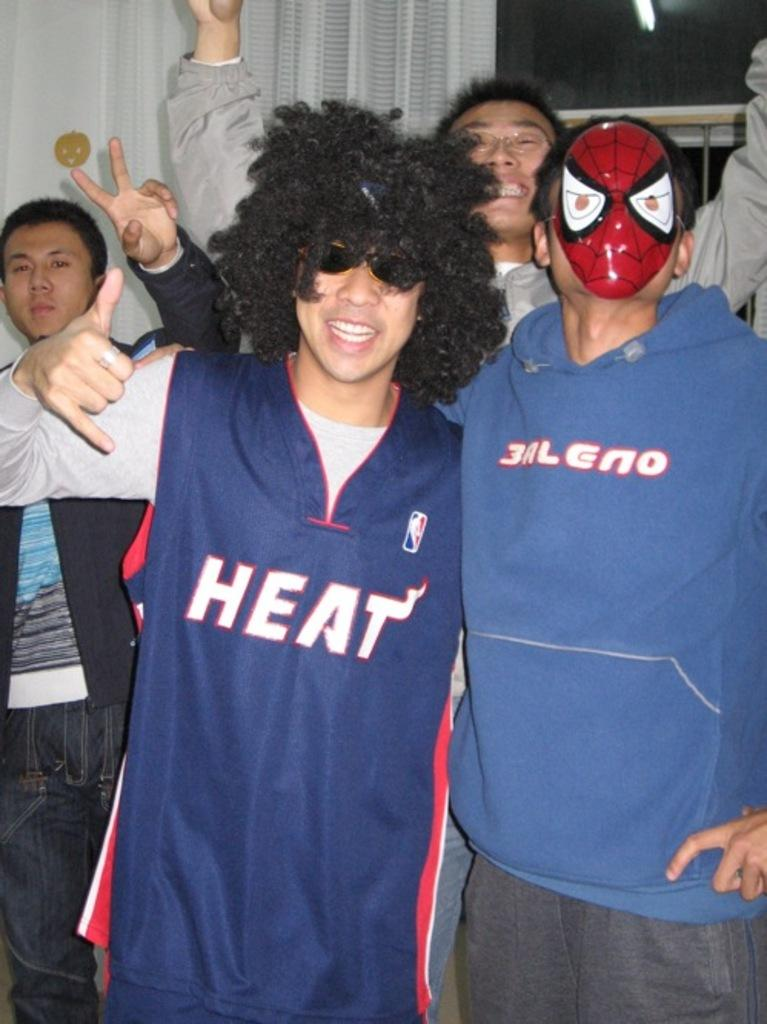<image>
Relay a brief, clear account of the picture shown. A man in a Heat jersey wears a wig and sunglasses. 